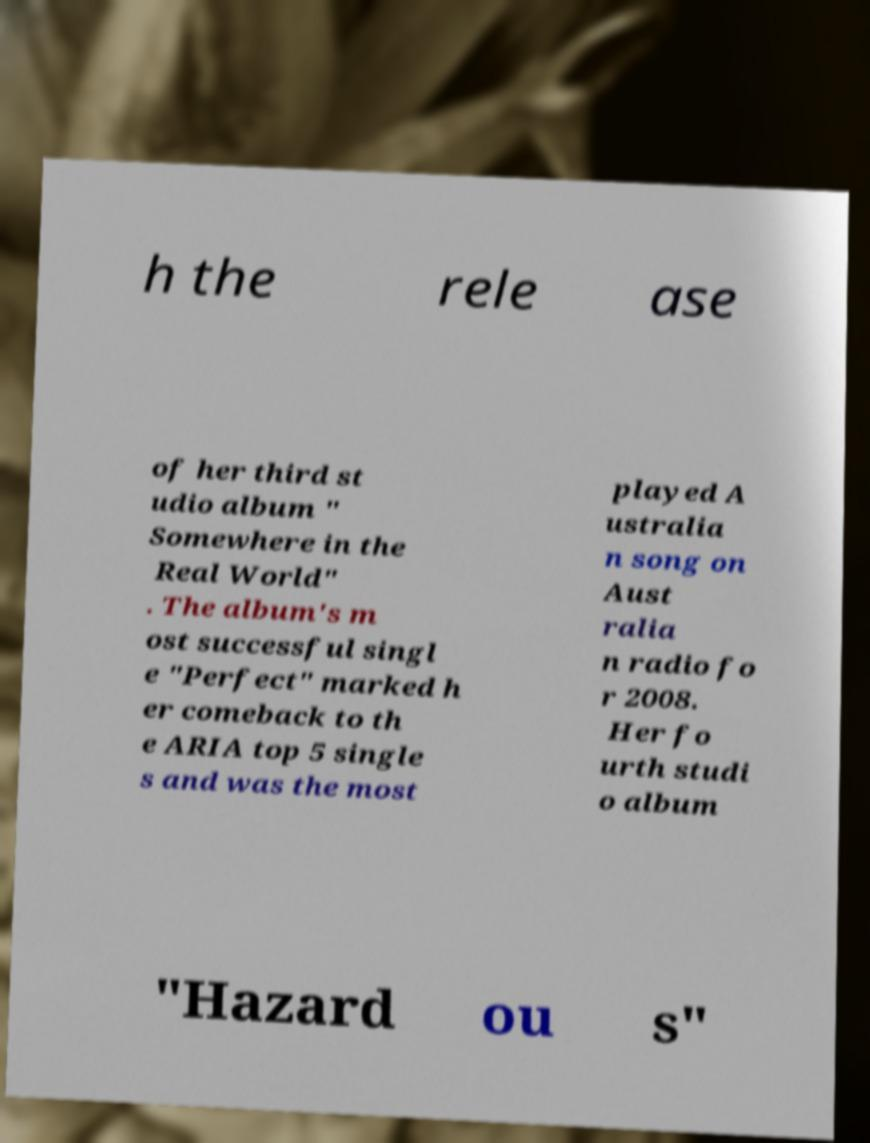There's text embedded in this image that I need extracted. Can you transcribe it verbatim? h the rele ase of her third st udio album " Somewhere in the Real World" . The album's m ost successful singl e "Perfect" marked h er comeback to th e ARIA top 5 single s and was the most played A ustralia n song on Aust ralia n radio fo r 2008. Her fo urth studi o album "Hazard ou s" 